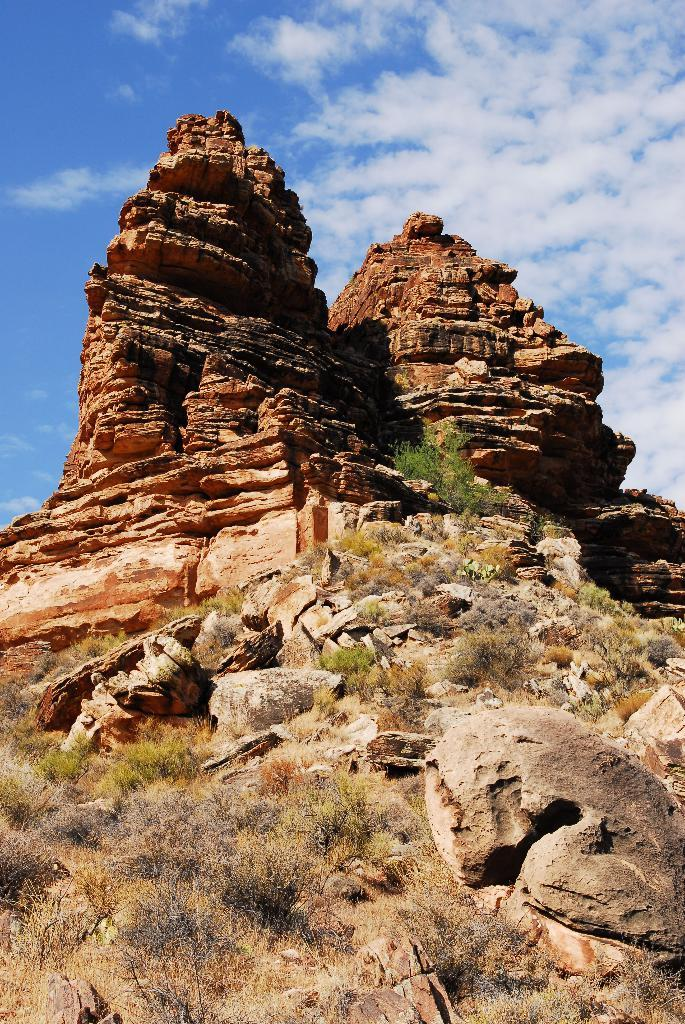What type of natural elements can be seen in the image? There are rocks and shrubs in the image. What is visible in the background of the image? The sky is visible in the background of the image. Are there any weather conditions indicated by the sky? Yes, clouds are present in the sky. What type of shoes can be seen hanging from the rocks in the image? There are no shoes present in the image; it only features rocks and shrubs. Is there any evidence of a crime scene in the image? There is no indication of a crime scene in the image; it is a natural scene with rocks, shrubs, and a sky with clouds. 